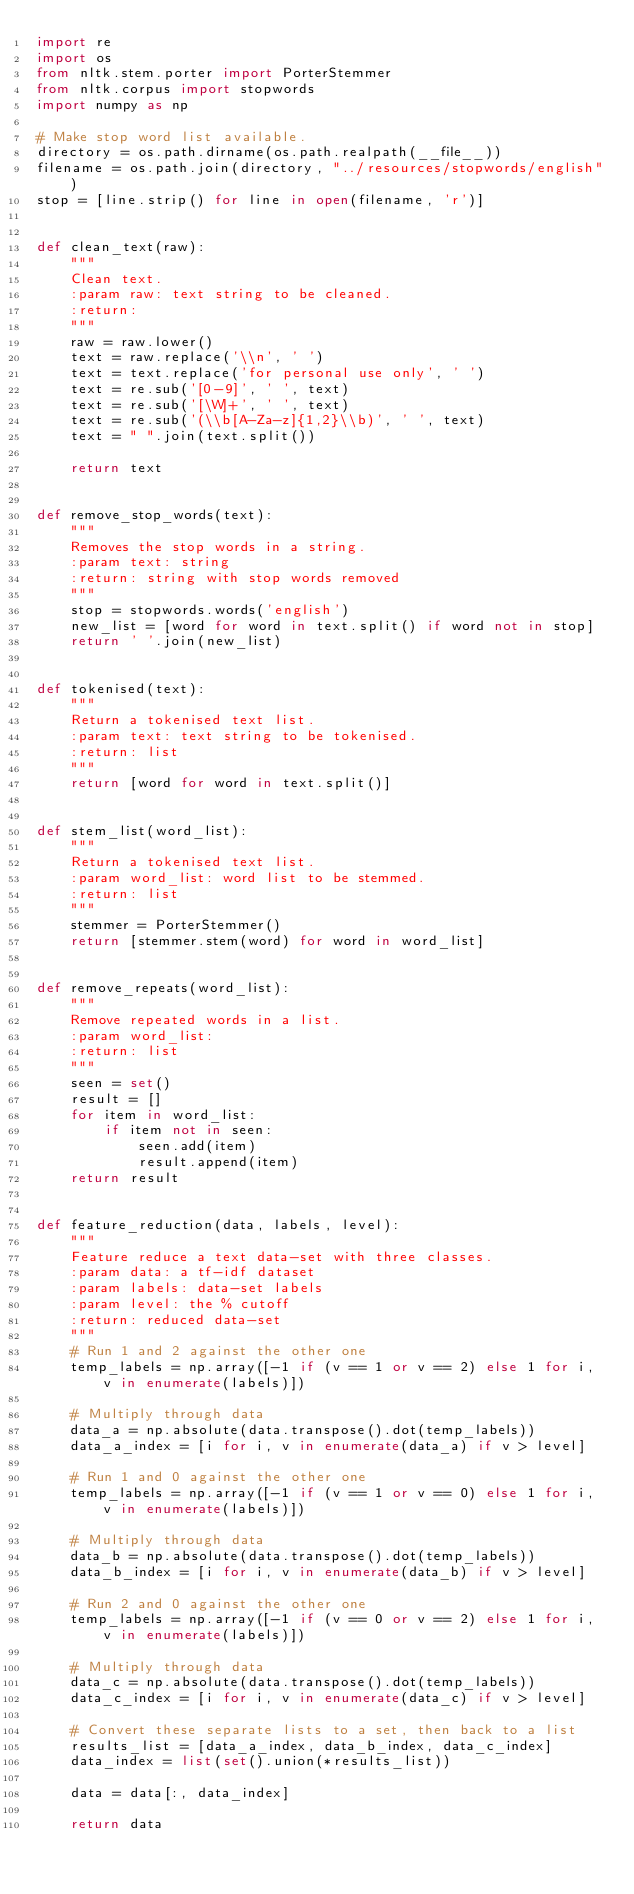Convert code to text. <code><loc_0><loc_0><loc_500><loc_500><_Python_>import re
import os
from nltk.stem.porter import PorterStemmer
from nltk.corpus import stopwords
import numpy as np

# Make stop word list available.
directory = os.path.dirname(os.path.realpath(__file__))
filename = os.path.join(directory, "../resources/stopwords/english")
stop = [line.strip() for line in open(filename, 'r')]


def clean_text(raw):
    """
    Clean text.
    :param raw: text string to be cleaned.
    :return:
    """
    raw = raw.lower()
    text = raw.replace('\\n', ' ')
    text = text.replace('for personal use only', ' ')
    text = re.sub('[0-9]', ' ', text)
    text = re.sub('[\W]+', ' ', text)
    text = re.sub('(\\b[A-Za-z]{1,2}\\b)', ' ', text)
    text = " ".join(text.split())

    return text


def remove_stop_words(text):
    """
    Removes the stop words in a string.
    :param text: string
    :return: string with stop words removed
    """
    stop = stopwords.words('english')
    new_list = [word for word in text.split() if word not in stop]
    return ' '.join(new_list)


def tokenised(text):
    """
    Return a tokenised text list.
    :param text: text string to be tokenised.
    :return: list
    """
    return [word for word in text.split()]


def stem_list(word_list):
    """
    Return a tokenised text list.
    :param word_list: word list to be stemmed.
    :return: list
    """
    stemmer = PorterStemmer()
    return [stemmer.stem(word) for word in word_list]


def remove_repeats(word_list):
    """
    Remove repeated words in a list.
    :param word_list:
    :return: list
    """
    seen = set()
    result = []
    for item in word_list:
        if item not in seen:
            seen.add(item)
            result.append(item)
    return result


def feature_reduction(data, labels, level):
    """
    Feature reduce a text data-set with three classes.
    :param data: a tf-idf dataset
    :param labels: data-set labels
    :param level: the % cutoff
    :return: reduced data-set
    """
    # Run 1 and 2 against the other one
    temp_labels = np.array([-1 if (v == 1 or v == 2) else 1 for i, v in enumerate(labels)])

    # Multiply through data
    data_a = np.absolute(data.transpose().dot(temp_labels))
    data_a_index = [i for i, v in enumerate(data_a) if v > level]

    # Run 1 and 0 against the other one
    temp_labels = np.array([-1 if (v == 1 or v == 0) else 1 for i, v in enumerate(labels)])

    # Multiply through data
    data_b = np.absolute(data.transpose().dot(temp_labels))
    data_b_index = [i for i, v in enumerate(data_b) if v > level]

    # Run 2 and 0 against the other one
    temp_labels = np.array([-1 if (v == 0 or v == 2) else 1 for i, v in enumerate(labels)])

    # Multiply through data
    data_c = np.absolute(data.transpose().dot(temp_labels))
    data_c_index = [i for i, v in enumerate(data_c) if v > level]

    # Convert these separate lists to a set, then back to a list
    results_list = [data_a_index, data_b_index, data_c_index]
    data_index = list(set().union(*results_list))

    data = data[:, data_index]

    return data
</code> 